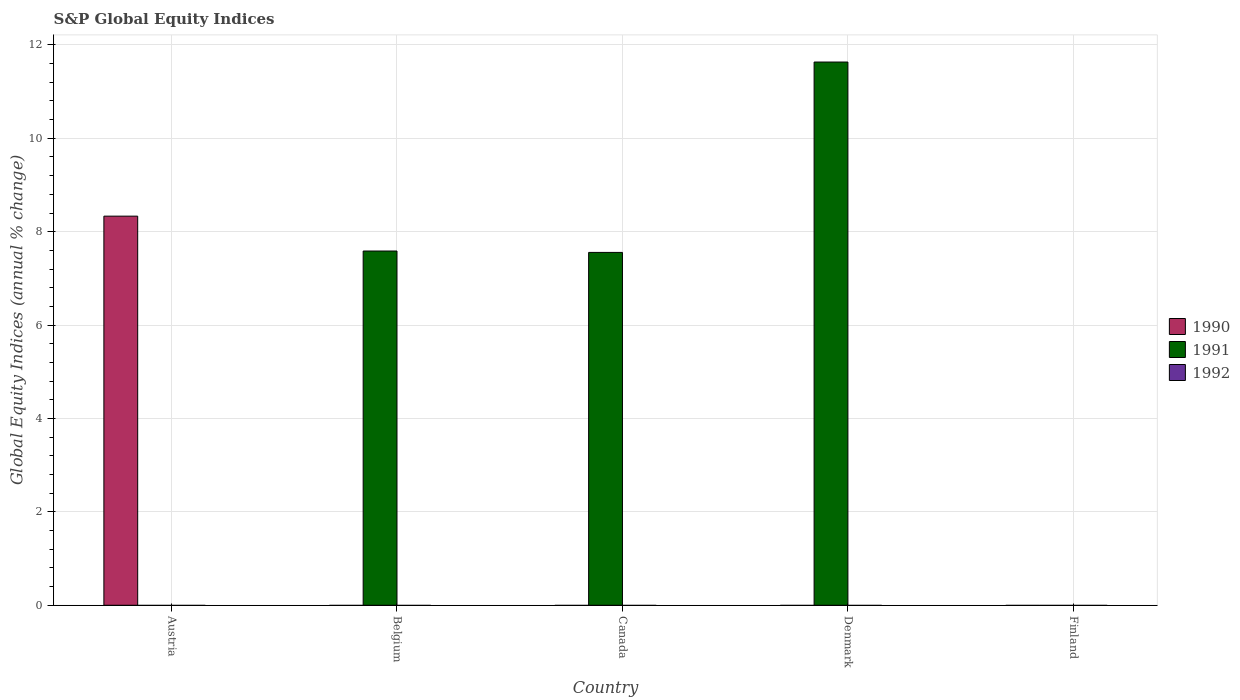Are the number of bars per tick equal to the number of legend labels?
Offer a very short reply. No. Are the number of bars on each tick of the X-axis equal?
Provide a short and direct response. No. How many bars are there on the 5th tick from the right?
Make the answer very short. 1. What is the global equity indices in 1991 in Canada?
Offer a terse response. 7.56. Across all countries, what is the maximum global equity indices in 1990?
Offer a terse response. 8.33. What is the total global equity indices in 1991 in the graph?
Your response must be concise. 26.78. What is the difference between the global equity indices in 1991 in Belgium and that in Denmark?
Offer a very short reply. -4.05. What is the difference between the global equity indices in 1990 in Finland and the global equity indices in 1992 in Denmark?
Make the answer very short. 0. What is the average global equity indices in 1990 per country?
Provide a short and direct response. 1.67. In how many countries, is the global equity indices in 1991 greater than 6.8 %?
Make the answer very short. 3. Is the global equity indices in 1991 in Belgium less than that in Canada?
Offer a terse response. No. What is the difference between the highest and the second highest global equity indices in 1991?
Offer a terse response. 4.08. What is the difference between the highest and the lowest global equity indices in 1990?
Offer a very short reply. 8.33. Is the sum of the global equity indices in 1991 in Canada and Denmark greater than the maximum global equity indices in 1990 across all countries?
Provide a short and direct response. Yes. How many bars are there?
Provide a short and direct response. 4. Are all the bars in the graph horizontal?
Make the answer very short. No. Does the graph contain any zero values?
Make the answer very short. Yes. Does the graph contain grids?
Your answer should be compact. Yes. How are the legend labels stacked?
Provide a short and direct response. Vertical. What is the title of the graph?
Give a very brief answer. S&P Global Equity Indices. Does "1966" appear as one of the legend labels in the graph?
Offer a terse response. No. What is the label or title of the Y-axis?
Give a very brief answer. Global Equity Indices (annual % change). What is the Global Equity Indices (annual % change) of 1990 in Austria?
Ensure brevity in your answer.  8.33. What is the Global Equity Indices (annual % change) in 1992 in Austria?
Keep it short and to the point. 0. What is the Global Equity Indices (annual % change) in 1991 in Belgium?
Provide a succinct answer. 7.59. What is the Global Equity Indices (annual % change) of 1992 in Belgium?
Make the answer very short. 0. What is the Global Equity Indices (annual % change) of 1991 in Canada?
Your answer should be very brief. 7.56. What is the Global Equity Indices (annual % change) of 1991 in Denmark?
Keep it short and to the point. 11.63. What is the Global Equity Indices (annual % change) in 1991 in Finland?
Offer a very short reply. 0. What is the Global Equity Indices (annual % change) in 1992 in Finland?
Make the answer very short. 0. Across all countries, what is the maximum Global Equity Indices (annual % change) of 1990?
Provide a succinct answer. 8.33. Across all countries, what is the maximum Global Equity Indices (annual % change) in 1991?
Your answer should be compact. 11.63. Across all countries, what is the minimum Global Equity Indices (annual % change) of 1990?
Provide a short and direct response. 0. What is the total Global Equity Indices (annual % change) of 1990 in the graph?
Ensure brevity in your answer.  8.33. What is the total Global Equity Indices (annual % change) of 1991 in the graph?
Give a very brief answer. 26.78. What is the difference between the Global Equity Indices (annual % change) of 1991 in Belgium and that in Canada?
Make the answer very short. 0.03. What is the difference between the Global Equity Indices (annual % change) of 1991 in Belgium and that in Denmark?
Ensure brevity in your answer.  -4.05. What is the difference between the Global Equity Indices (annual % change) of 1991 in Canada and that in Denmark?
Give a very brief answer. -4.08. What is the difference between the Global Equity Indices (annual % change) of 1990 in Austria and the Global Equity Indices (annual % change) of 1991 in Belgium?
Offer a terse response. 0.75. What is the difference between the Global Equity Indices (annual % change) in 1990 in Austria and the Global Equity Indices (annual % change) in 1991 in Canada?
Offer a very short reply. 0.78. What is the difference between the Global Equity Indices (annual % change) in 1990 in Austria and the Global Equity Indices (annual % change) in 1991 in Denmark?
Ensure brevity in your answer.  -3.3. What is the average Global Equity Indices (annual % change) in 1990 per country?
Make the answer very short. 1.67. What is the average Global Equity Indices (annual % change) of 1991 per country?
Ensure brevity in your answer.  5.36. What is the average Global Equity Indices (annual % change) of 1992 per country?
Give a very brief answer. 0. What is the ratio of the Global Equity Indices (annual % change) of 1991 in Belgium to that in Canada?
Your answer should be compact. 1. What is the ratio of the Global Equity Indices (annual % change) in 1991 in Belgium to that in Denmark?
Make the answer very short. 0.65. What is the ratio of the Global Equity Indices (annual % change) of 1991 in Canada to that in Denmark?
Ensure brevity in your answer.  0.65. What is the difference between the highest and the second highest Global Equity Indices (annual % change) of 1991?
Provide a succinct answer. 4.05. What is the difference between the highest and the lowest Global Equity Indices (annual % change) of 1990?
Your response must be concise. 8.33. What is the difference between the highest and the lowest Global Equity Indices (annual % change) in 1991?
Provide a short and direct response. 11.63. 